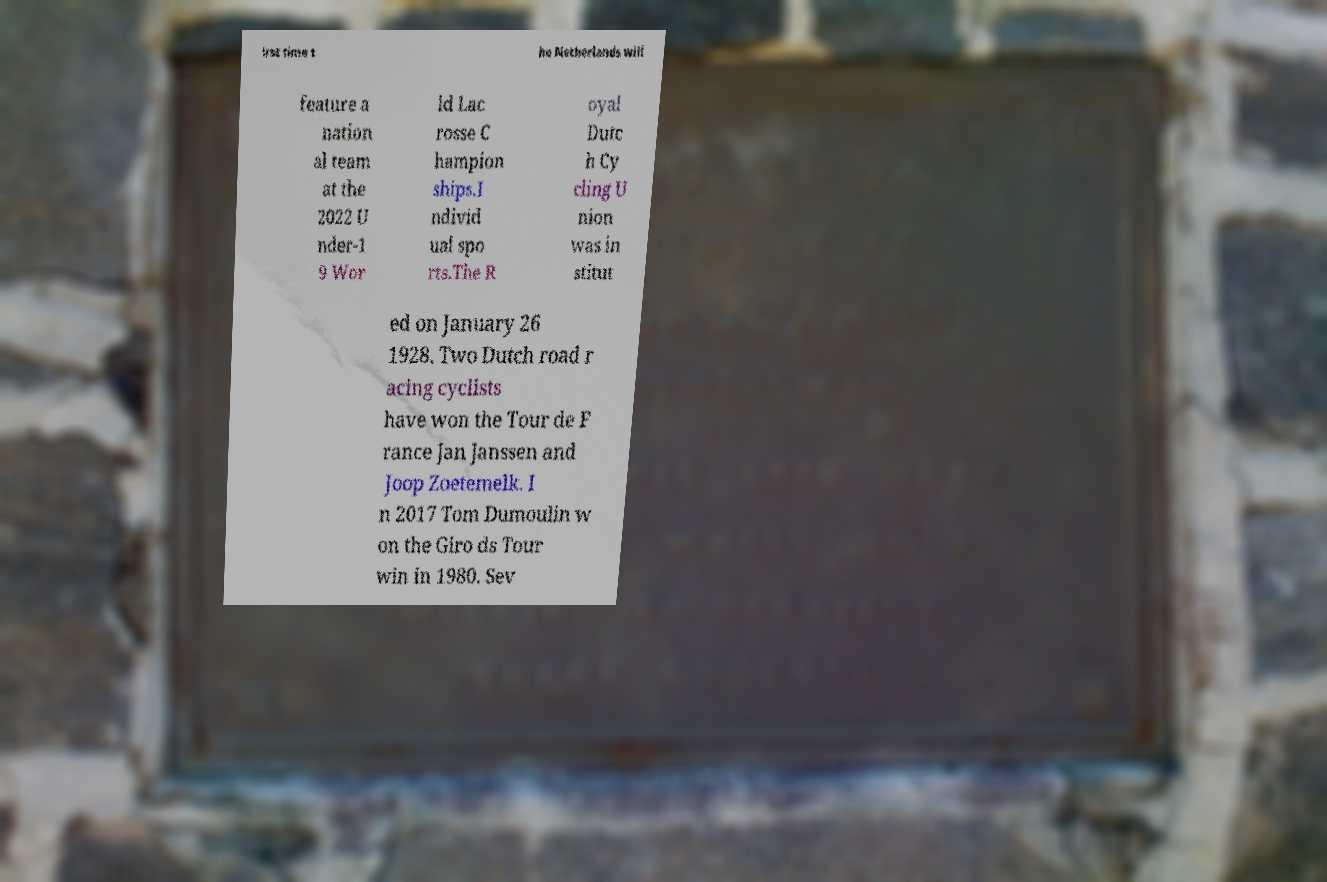Please identify and transcribe the text found in this image. irst time t he Netherlands will feature a nation al team at the 2022 U nder-1 9 Wor ld Lac rosse C hampion ships.I ndivid ual spo rts.The R oyal Dutc h Cy cling U nion was in stitut ed on January 26 1928. Two Dutch road r acing cyclists have won the Tour de F rance Jan Janssen and Joop Zoetemelk. I n 2017 Tom Dumoulin w on the Giro ds Tour win in 1980. Sev 